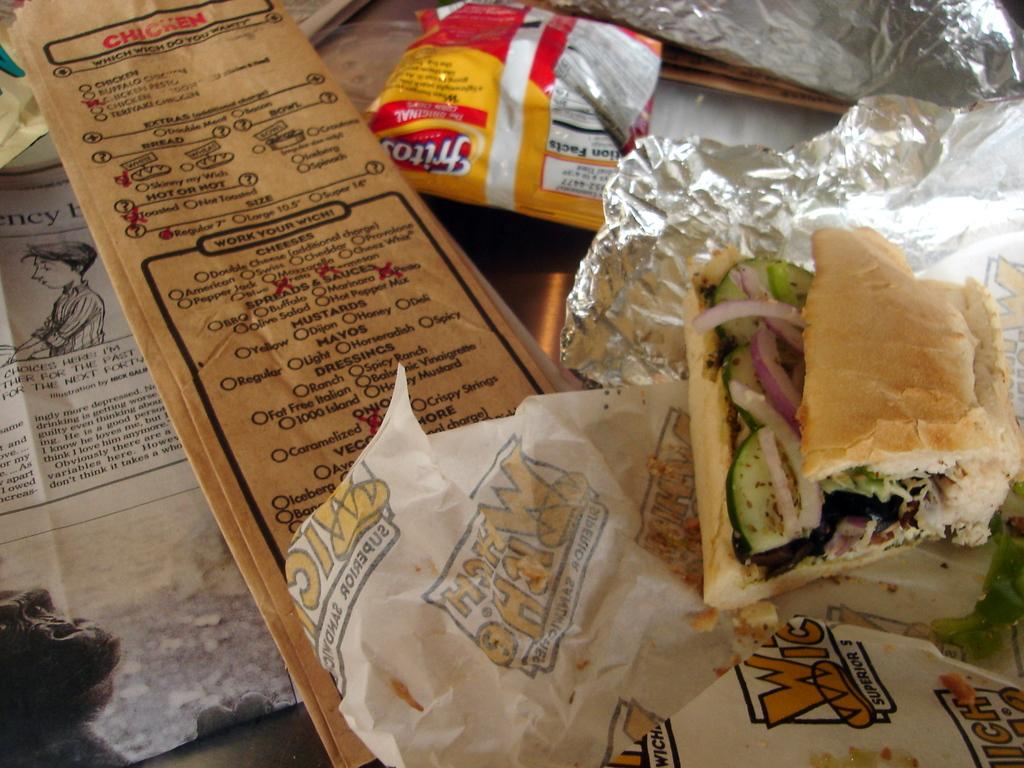What is the main subject of the image? The main subject of the image is food. How is the food presented in the image? The food is on a silver foil. What colors can be seen in the image? There are yellow, red, and brown colors present in the image. What other object is visible in the image besides the food? There is a paper in the image. Can you see any cows grazing in the image? No, there are no cows present in the image. What type of mint is used as a garnish on the food in the image? There is no mint visible in the image, as it only features food on a silver foil and a paper. 